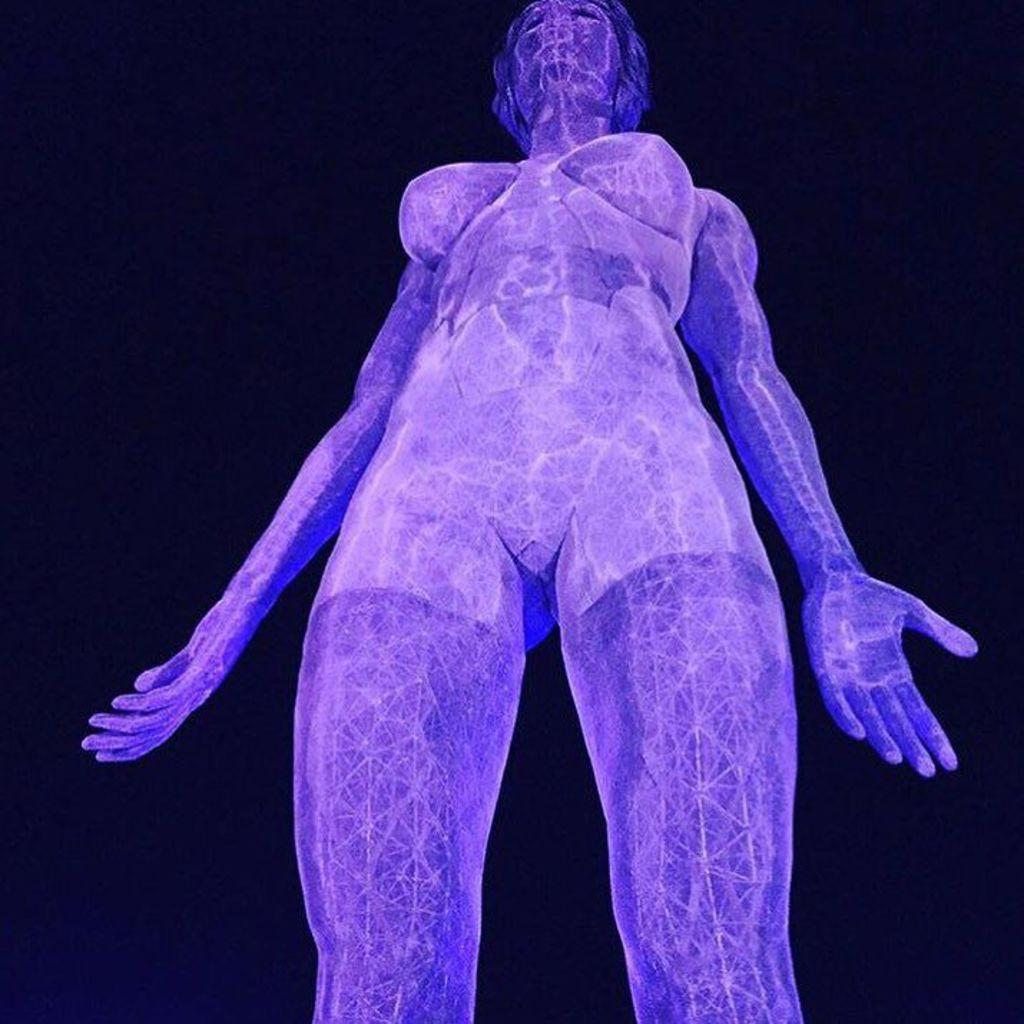What type of media is the image? The image is an animation. What is depicted in the animation? There is a picture of a woman in the animation. How would you describe the background of the animation? The background of the animation is dark. What is the woman discussing with the sugar in the animation? There is no sugar present in the animation, and the woman is not depicted as having a discussion with any object or person. 